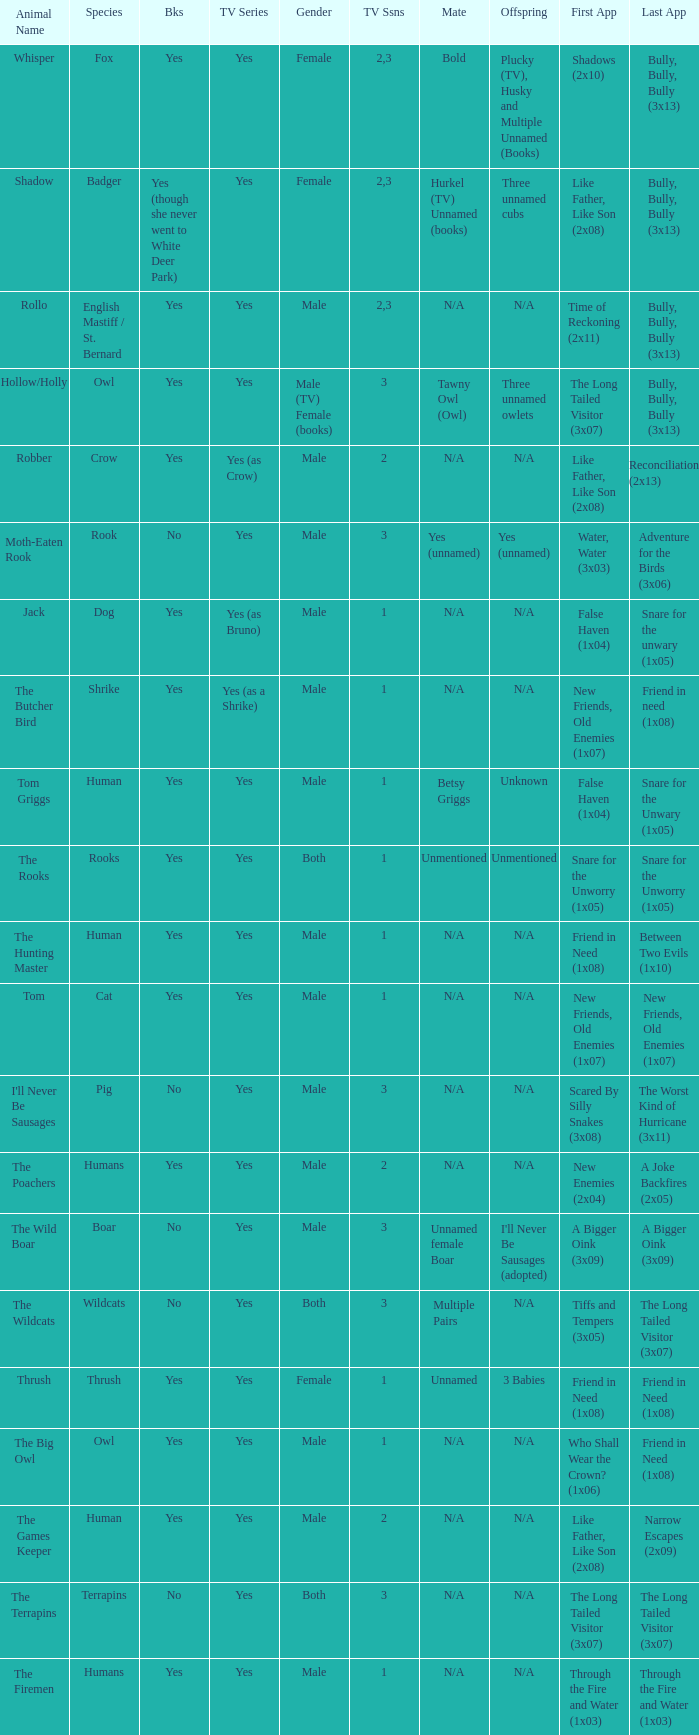What is the smallest season for a tv series with a yes and human was the species? 1.0. 